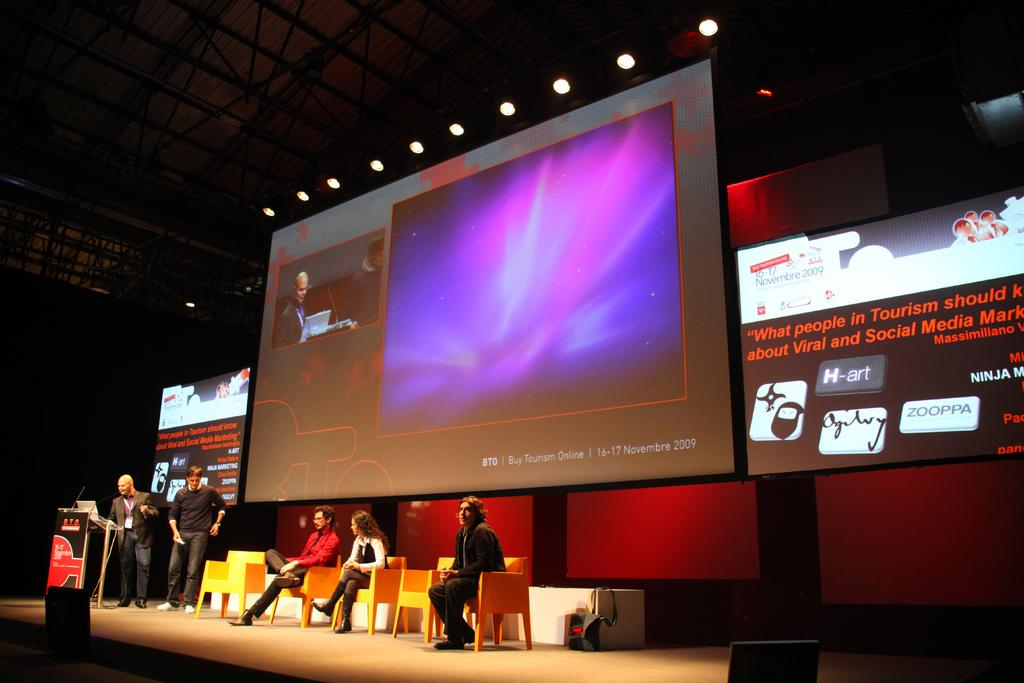<image>
Share a concise interpretation of the image provided. A large monitor displays a BTO company name. 